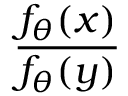<formula> <loc_0><loc_0><loc_500><loc_500>\frac { f _ { \theta } ( x ) } { f _ { \theta } ( y ) }</formula> 